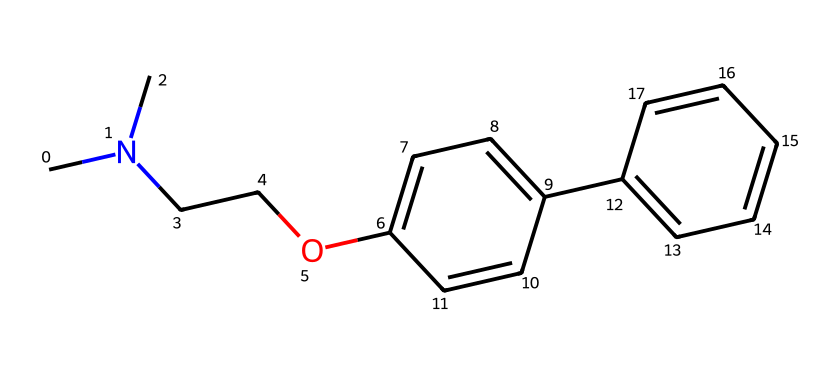What is the name of the chemical represented by this SMILES? The SMILES representation corresponds to a drug commonly known as Diphenhydramine, which is an antihistamine. It can be identified by its structure and matches with known chemical databases.
Answer: Diphenhydramine How many carbon atoms are in this chemical? By analyzing the SMILES representation, you can count the number of 'C' characters, which represents carbon atoms. There are 18 carbon atoms in total.
Answer: 18 What type of drug is represented by this chemical? This chemical is classified as an antihistamine due to its primary function of blocking histamine receptors to alleviate allergy symptoms.
Answer: antihistamine Does this chemical contain a nitrogen atom? In the SMILES notation, the presence of 'N' indicates that there is at least one nitrogen atom within the structure.
Answer: yes What functional group is present in this chemical? The chemical structure contains an ether functional group (R-O-R') where 'O' is surrounded by carbon chains, which is indicated by the oxygen atom in the SMILES.
Answer: ether What potential side effect could this drug have? Common side effects of antihistamines like this drug can include drowsiness, which is a direct effect of its mechanism in blocking histamine.
Answer: drowsiness Can this chemical cause interactions with programming focus? Due to the sedative effects associated with antihistamines like Diphenhydramine, it can impact concentration and cognitive function necessary for programming.
Answer: cognitive impairment 